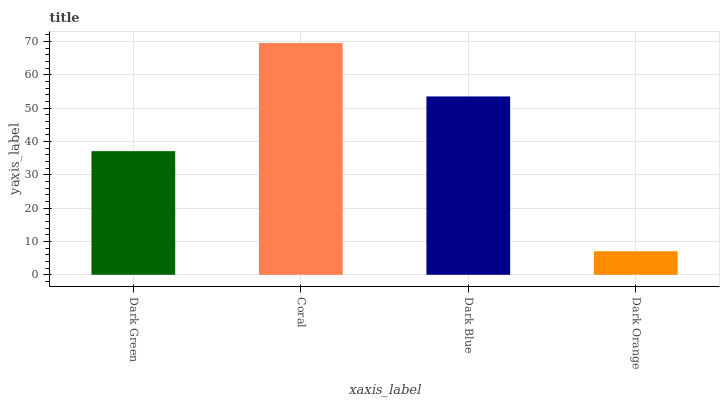Is Dark Orange the minimum?
Answer yes or no. Yes. Is Coral the maximum?
Answer yes or no. Yes. Is Dark Blue the minimum?
Answer yes or no. No. Is Dark Blue the maximum?
Answer yes or no. No. Is Coral greater than Dark Blue?
Answer yes or no. Yes. Is Dark Blue less than Coral?
Answer yes or no. Yes. Is Dark Blue greater than Coral?
Answer yes or no. No. Is Coral less than Dark Blue?
Answer yes or no. No. Is Dark Blue the high median?
Answer yes or no. Yes. Is Dark Green the low median?
Answer yes or no. Yes. Is Coral the high median?
Answer yes or no. No. Is Coral the low median?
Answer yes or no. No. 